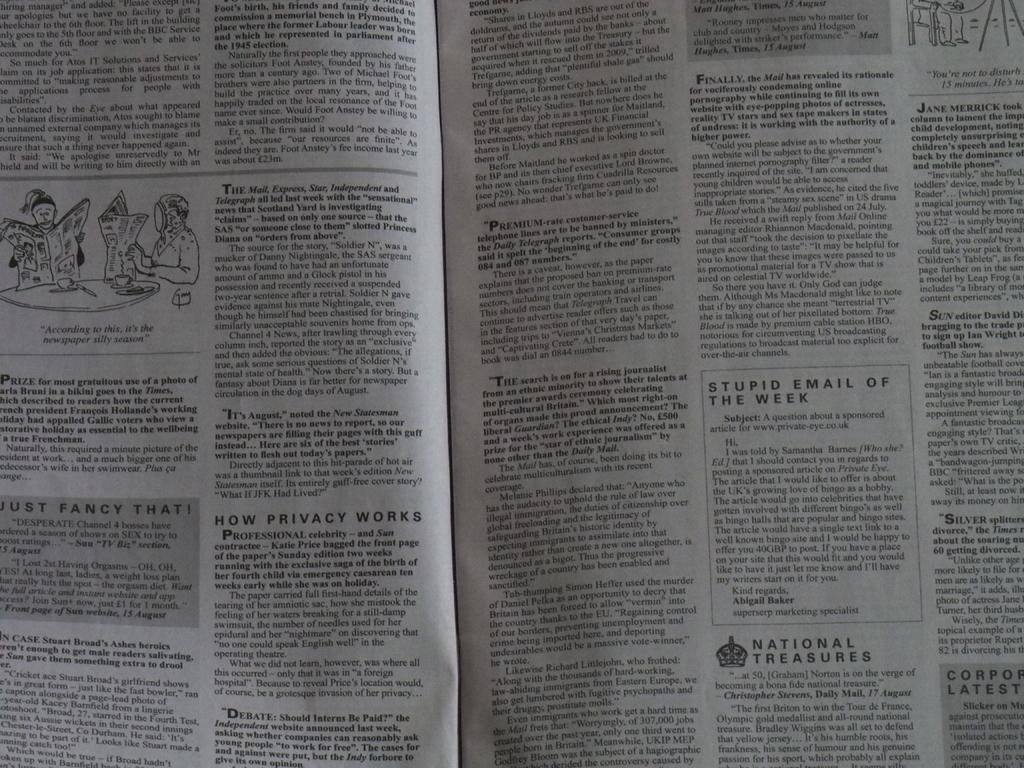<image>
Relay a brief, clear account of the picture shown. A newspaper opened up to a page with one title called How Privacy Works. 